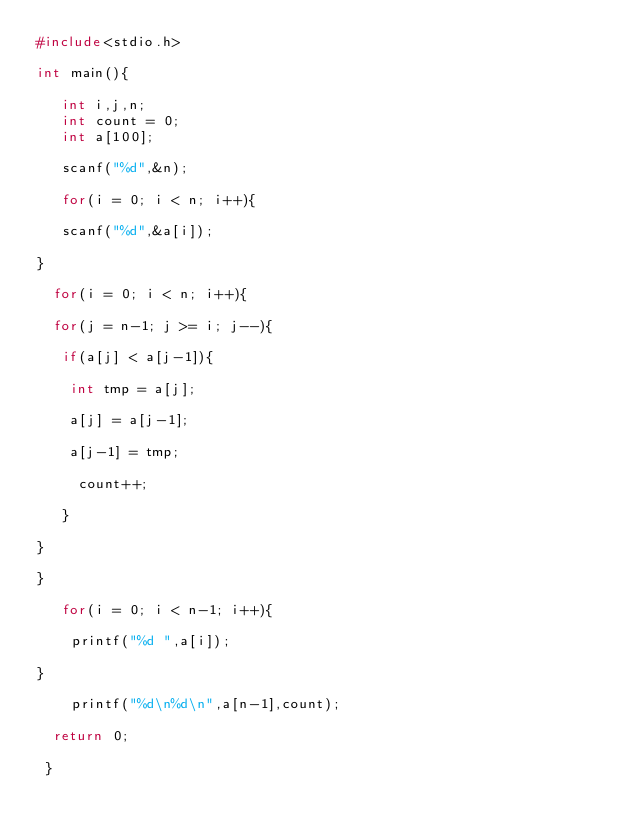<code> <loc_0><loc_0><loc_500><loc_500><_C_>#include<stdio.h>

int main(){

   int i,j,n;
   int count = 0;
   int a[100];

   scanf("%d",&n);

   for(i = 0; i < n; i++){

   scanf("%d",&a[i]);

}

  for(i = 0; i < n; i++){

  for(j = n-1; j >= i; j--){

   if(a[j] < a[j-1]){

    int tmp = a[j];

    a[j] = a[j-1];

    a[j-1] = tmp;

     count++;

   }

}

}

   for(i = 0; i < n-1; i++){

    printf("%d ",a[i]);

}

    printf("%d\n%d\n",a[n-1],count);

  return 0;

 }</code> 